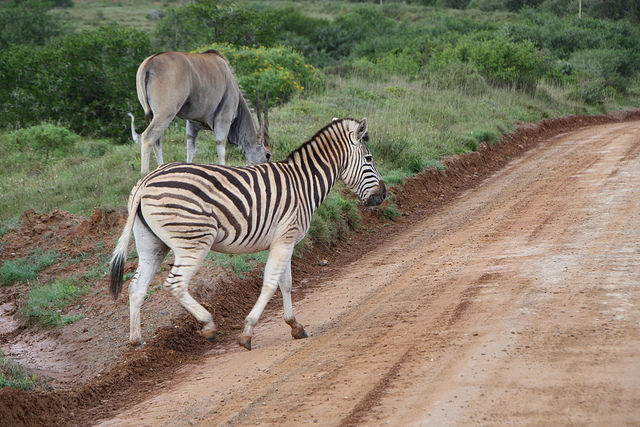How do the stripes of the zebra help it in the wild? Zebra stripes have been a topic of fascination and study for biologists. Several theories suggest their purpose, such as camouflage to help break up the outline of the zebra in tall grasses, confusing predators by making it harder to pick out individual animals when they move together in a herd, and as a method to regulate body temperature. Moreover, the unique striping pattern can help zebras identify one another. It is also theorized that the stripes may deter biting flies, which are less likely to land on striped surfaces. 